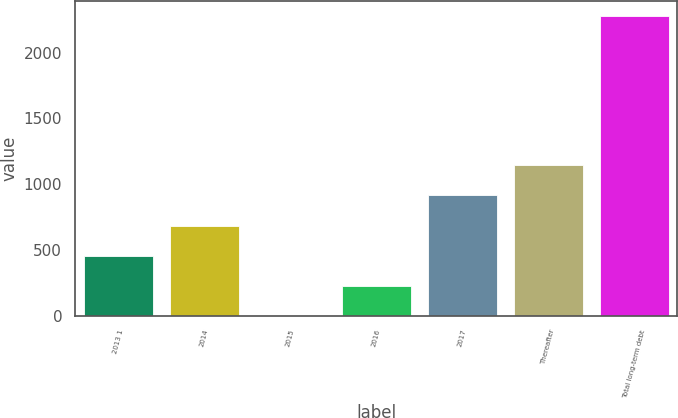Convert chart to OTSL. <chart><loc_0><loc_0><loc_500><loc_500><bar_chart><fcel>2013 1<fcel>2014<fcel>2015<fcel>2016<fcel>2017<fcel>Thereafter<fcel>Total long-term debt<nl><fcel>455.56<fcel>683.29<fcel>0.1<fcel>227.83<fcel>913.8<fcel>1141.53<fcel>2277.4<nl></chart> 